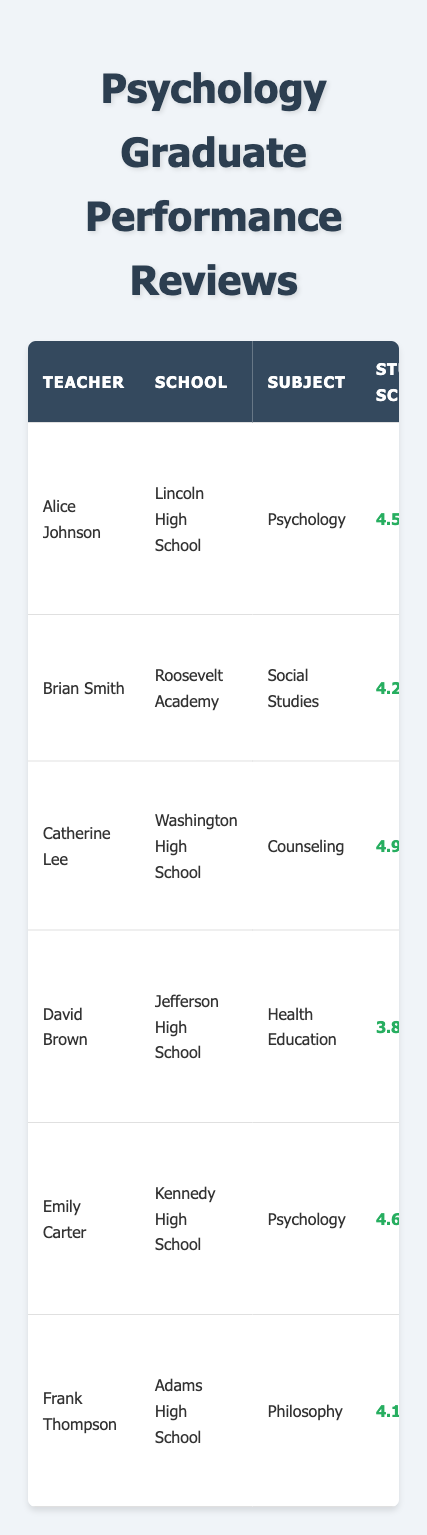What is the student feedback score of Alice Johnson? Alice Johnson's student feedback score can be found directly in the table under "Student Score," where her score is listed as 4.5.
Answer: 4.5 Which teacher has the highest administrator feedback score? To find this, I compare the "Admin Score" values for each teacher. Catherine Lee has the highest score of 4.7.
Answer: Catherine Lee What are the areas for improvement for Emily Carter? Emily Carter's areas for improvement are listed in the table. They are indicated as "Lesson Structure."
Answer: Lesson Structure Is David Brown's student feedback score below 4.0? By checking the "Student Score" for David Brown, which is 3.8, I confirm that it is indeed below 4.0.
Answer: Yes Calculate the average student feedback score for the psychology teachers listed. The student feedback scores for the psychology teachers are 4.5 (Alice Johnson) and 4.6 (Emily Carter). The average can be calculated as (4.5 + 4.6) / 2 = 4.55.
Answer: 4.55 What strengths does Frank Thompson possess? The strengths for Frank Thompson are detailed under "Strengths" in the table, where they are listed as "Subject Matter Expertise, Debate Facilitation."
Answer: Subject Matter Expertise, Debate Facilitation Which teacher has the lowest student feedback score? By comparing all the "Student Score" entries, David Brown has the lowest score of 3.8.
Answer: David Brown Did any teacher receive a student feedback score of 4.9? I check the "Student Score" for each teacher and see that Catherine Lee has a student feedback score of 4.9.
Answer: Yes Compare the administrator feedback scores of Alice Johnson and David Brown. Alice Johnson has an administrator feedback score of 4.8, while David Brown has 4.1. The comparison shows that Alice Johnson's score is higher.
Answer: Alice Johnson has a higher score What improvements are suggested for Catherine Lee? Catherine Lee's areas for improvement are listed as "Administrative Tasks" in the table.
Answer: Administrative Tasks 